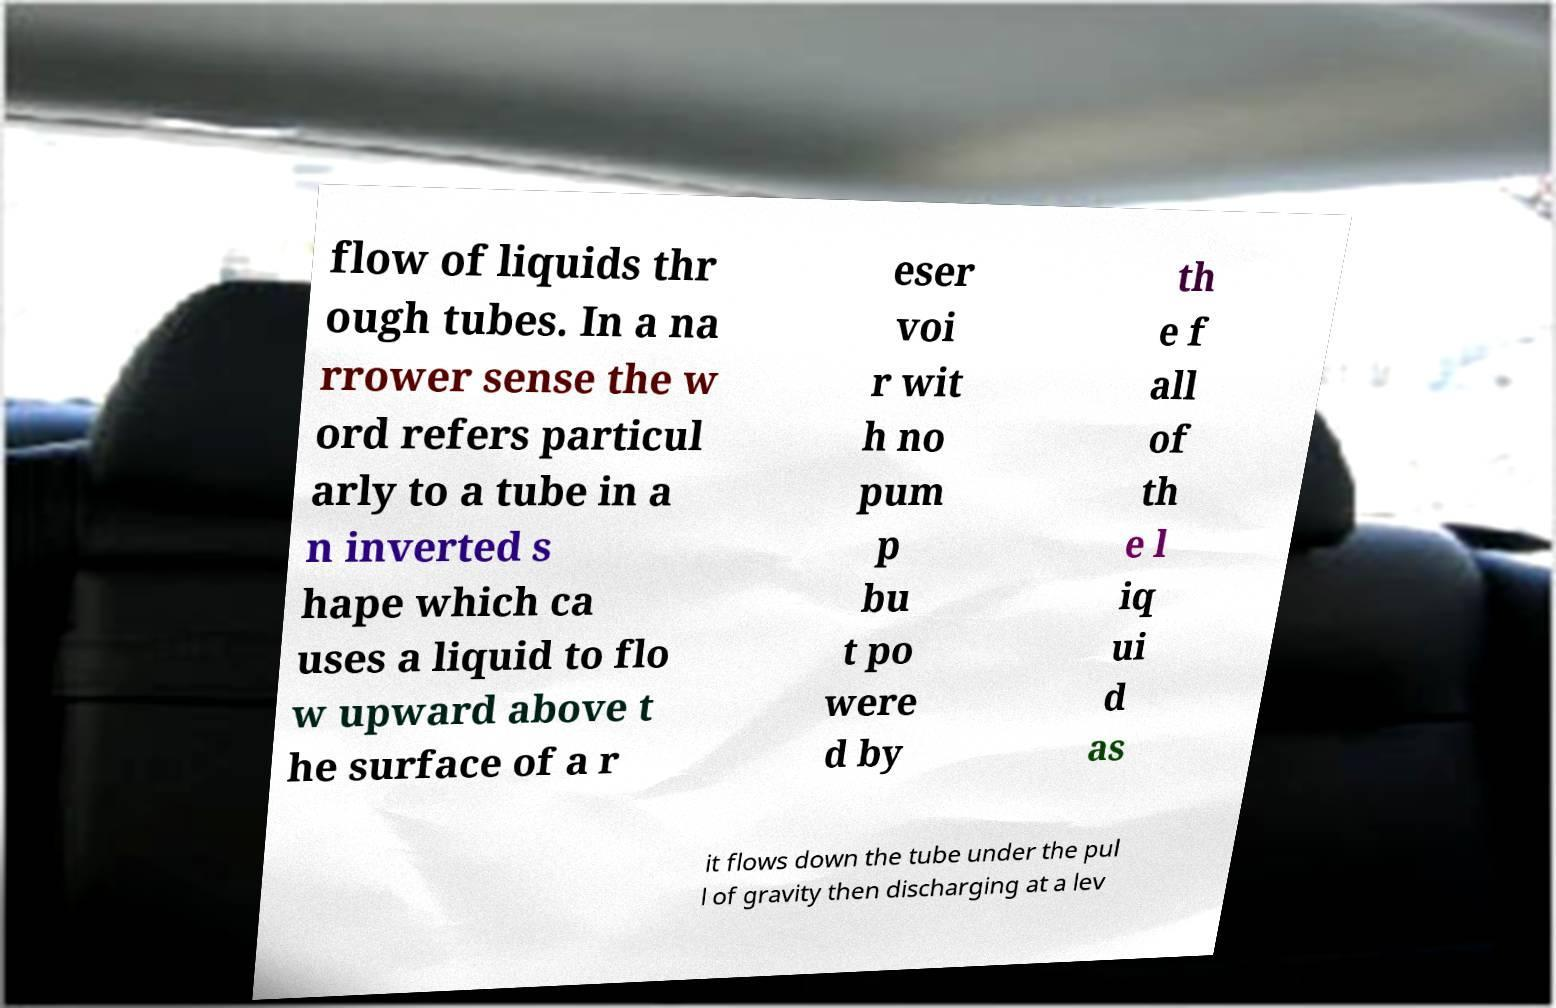I need the written content from this picture converted into text. Can you do that? flow of liquids thr ough tubes. In a na rrower sense the w ord refers particul arly to a tube in a n inverted s hape which ca uses a liquid to flo w upward above t he surface of a r eser voi r wit h no pum p bu t po were d by th e f all of th e l iq ui d as it flows down the tube under the pul l of gravity then discharging at a lev 